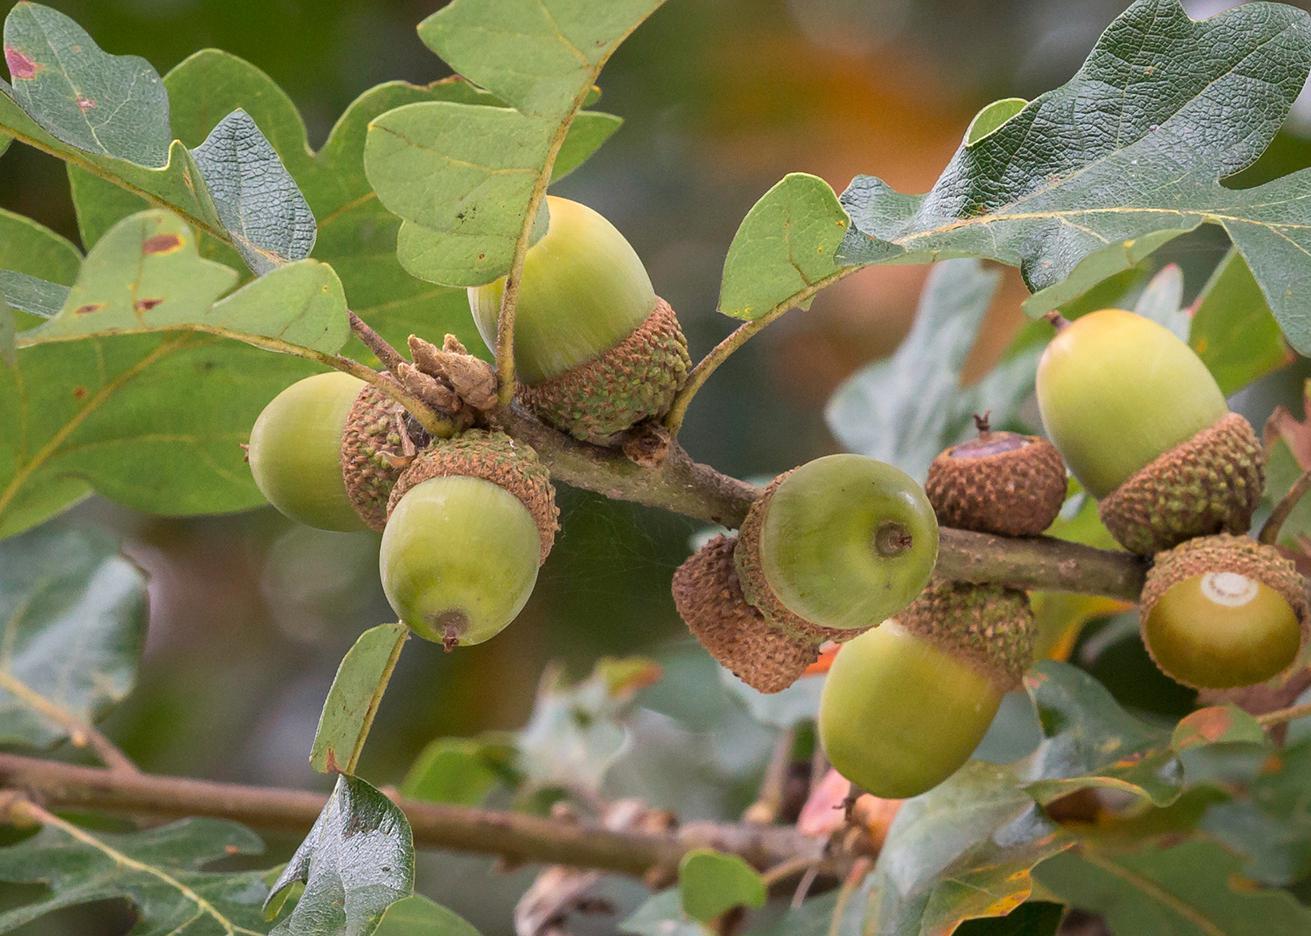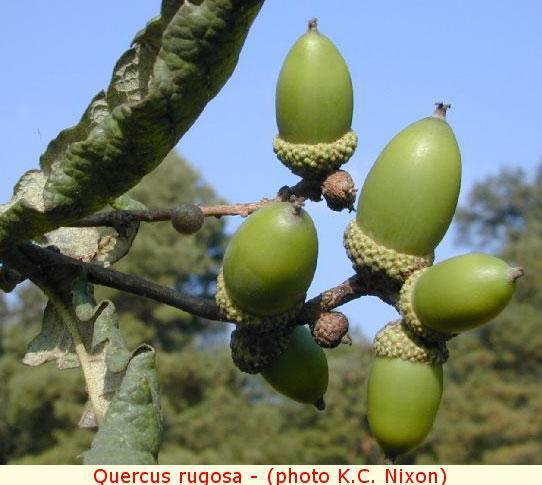The first image is the image on the left, the second image is the image on the right. Considering the images on both sides, is "There are more than five acorns." valid? Answer yes or no. Yes. The first image is the image on the left, the second image is the image on the right. Analyze the images presented: Is the assertion "The combined images contain no more than five acorns, and all acorns pictured have the same basic shape." valid? Answer yes or no. No. 